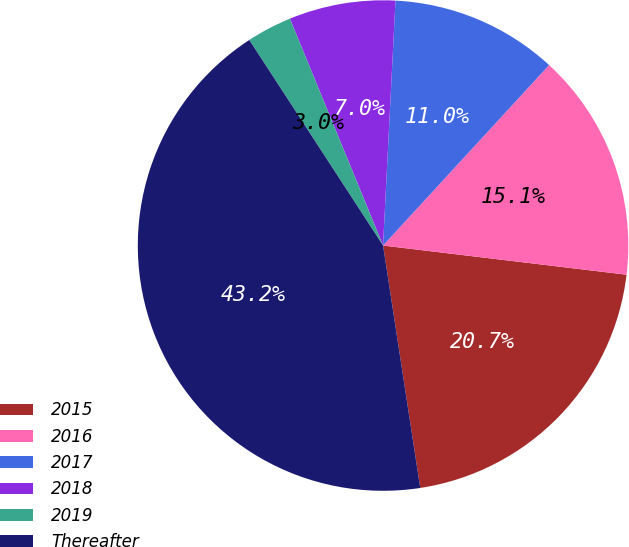<chart> <loc_0><loc_0><loc_500><loc_500><pie_chart><fcel>2015<fcel>2016<fcel>2017<fcel>2018<fcel>2019<fcel>Thereafter<nl><fcel>20.68%<fcel>15.06%<fcel>11.03%<fcel>7.01%<fcel>2.98%<fcel>43.24%<nl></chart> 